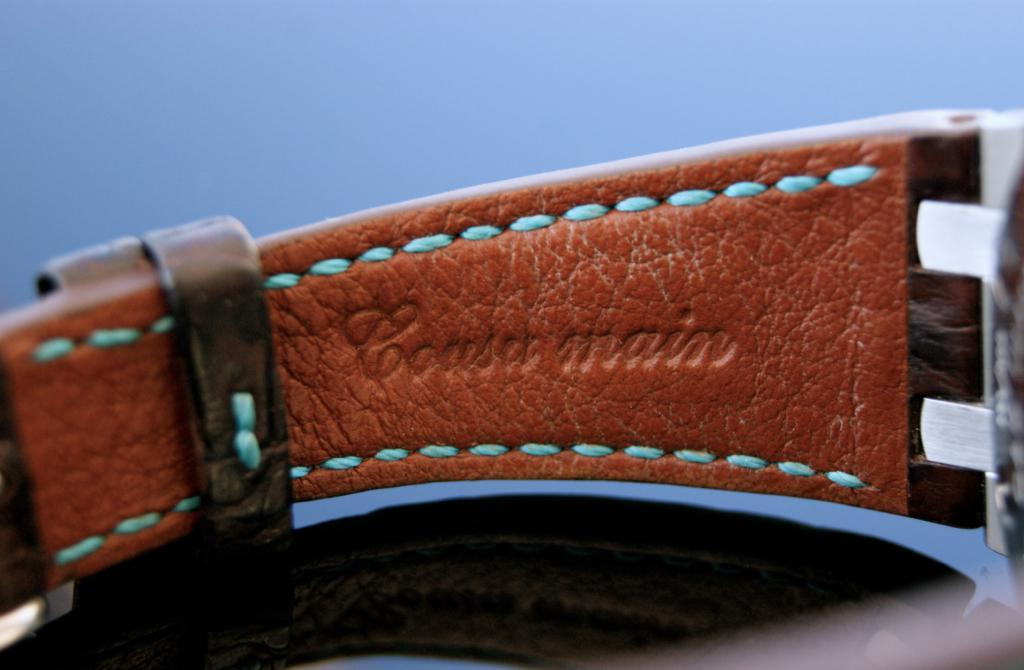<image>
Provide a brief description of the given image. The writing on the belt says coast main 